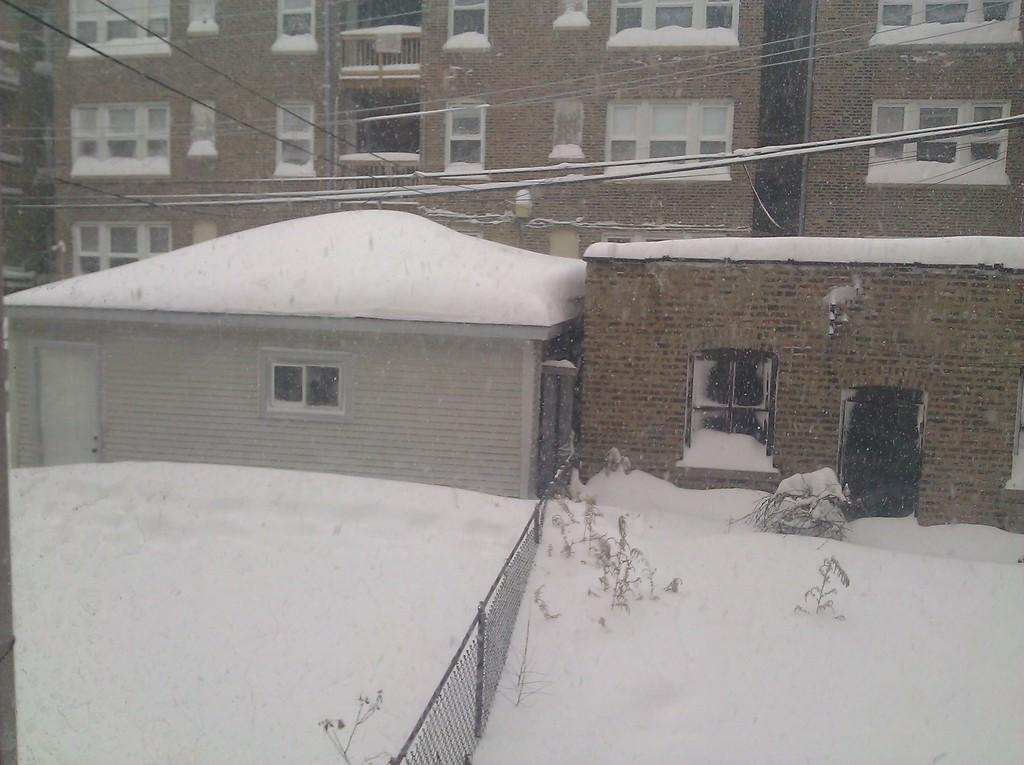What type of vegetation is on the left side of the image? There are plants on the left side of the image. What is the surface on the left side of the image? There is a snowy surface on the left side of the image. What is the purpose of the fence on the left side of the image? The fence on the left side of the image is likely used to mark boundaries or keep animals in or out. What can be seen in the background of the image? There are cables and buildings with windows in the background of the image. How many chickens are sitting on the stove in the image? There are no chickens or stoves present in the image. What type of drawer can be seen in the image? There is no drawer present in the image. 